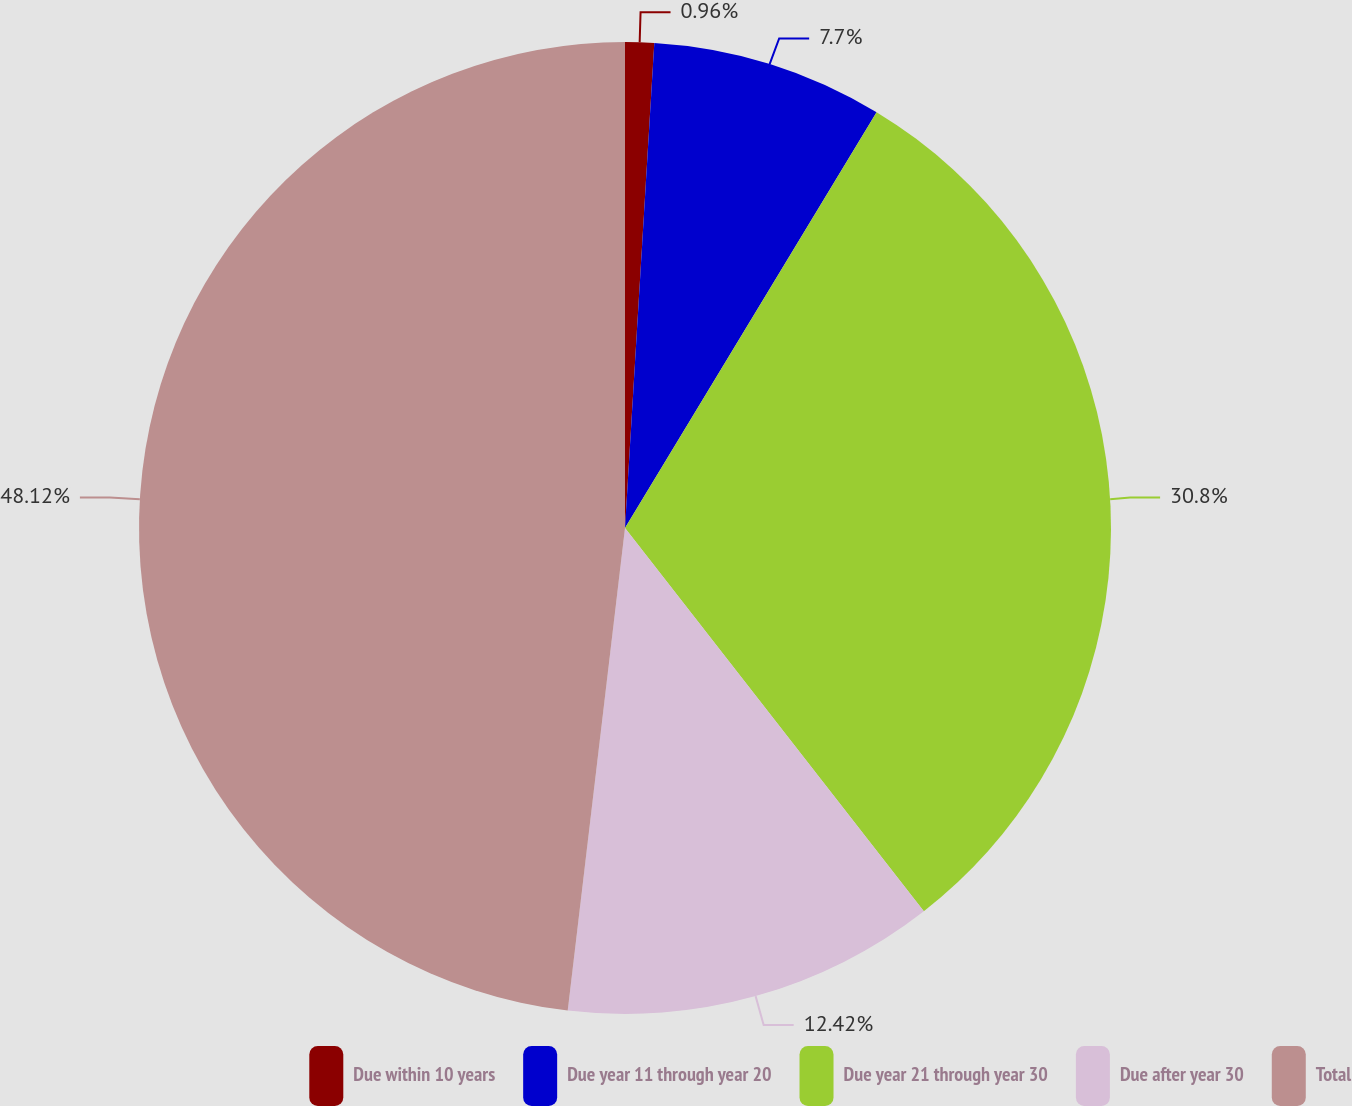Convert chart to OTSL. <chart><loc_0><loc_0><loc_500><loc_500><pie_chart><fcel>Due within 10 years<fcel>Due year 11 through year 20<fcel>Due year 21 through year 30<fcel>Due after year 30<fcel>Total<nl><fcel>0.96%<fcel>7.7%<fcel>30.8%<fcel>12.42%<fcel>48.12%<nl></chart> 